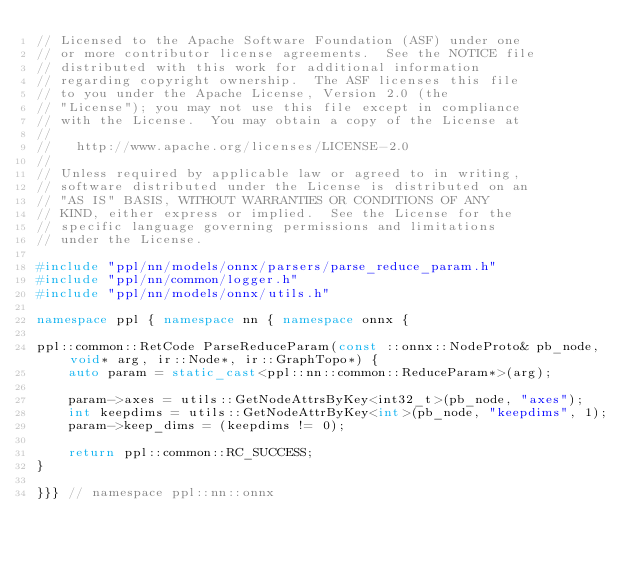<code> <loc_0><loc_0><loc_500><loc_500><_C++_>// Licensed to the Apache Software Foundation (ASF) under one
// or more contributor license agreements.  See the NOTICE file
// distributed with this work for additional information
// regarding copyright ownership.  The ASF licenses this file
// to you under the Apache License, Version 2.0 (the
// "License"); you may not use this file except in compliance
// with the License.  You may obtain a copy of the License at
//
//   http://www.apache.org/licenses/LICENSE-2.0
//
// Unless required by applicable law or agreed to in writing,
// software distributed under the License is distributed on an
// "AS IS" BASIS, WITHOUT WARRANTIES OR CONDITIONS OF ANY
// KIND, either express or implied.  See the License for the
// specific language governing permissions and limitations
// under the License.

#include "ppl/nn/models/onnx/parsers/parse_reduce_param.h"
#include "ppl/nn/common/logger.h"
#include "ppl/nn/models/onnx/utils.h"

namespace ppl { namespace nn { namespace onnx {

ppl::common::RetCode ParseReduceParam(const ::onnx::NodeProto& pb_node, void* arg, ir::Node*, ir::GraphTopo*) {
    auto param = static_cast<ppl::nn::common::ReduceParam*>(arg);

    param->axes = utils::GetNodeAttrsByKey<int32_t>(pb_node, "axes");
    int keepdims = utils::GetNodeAttrByKey<int>(pb_node, "keepdims", 1);
    param->keep_dims = (keepdims != 0);

    return ppl::common::RC_SUCCESS;
}

}}} // namespace ppl::nn::onnx
</code> 